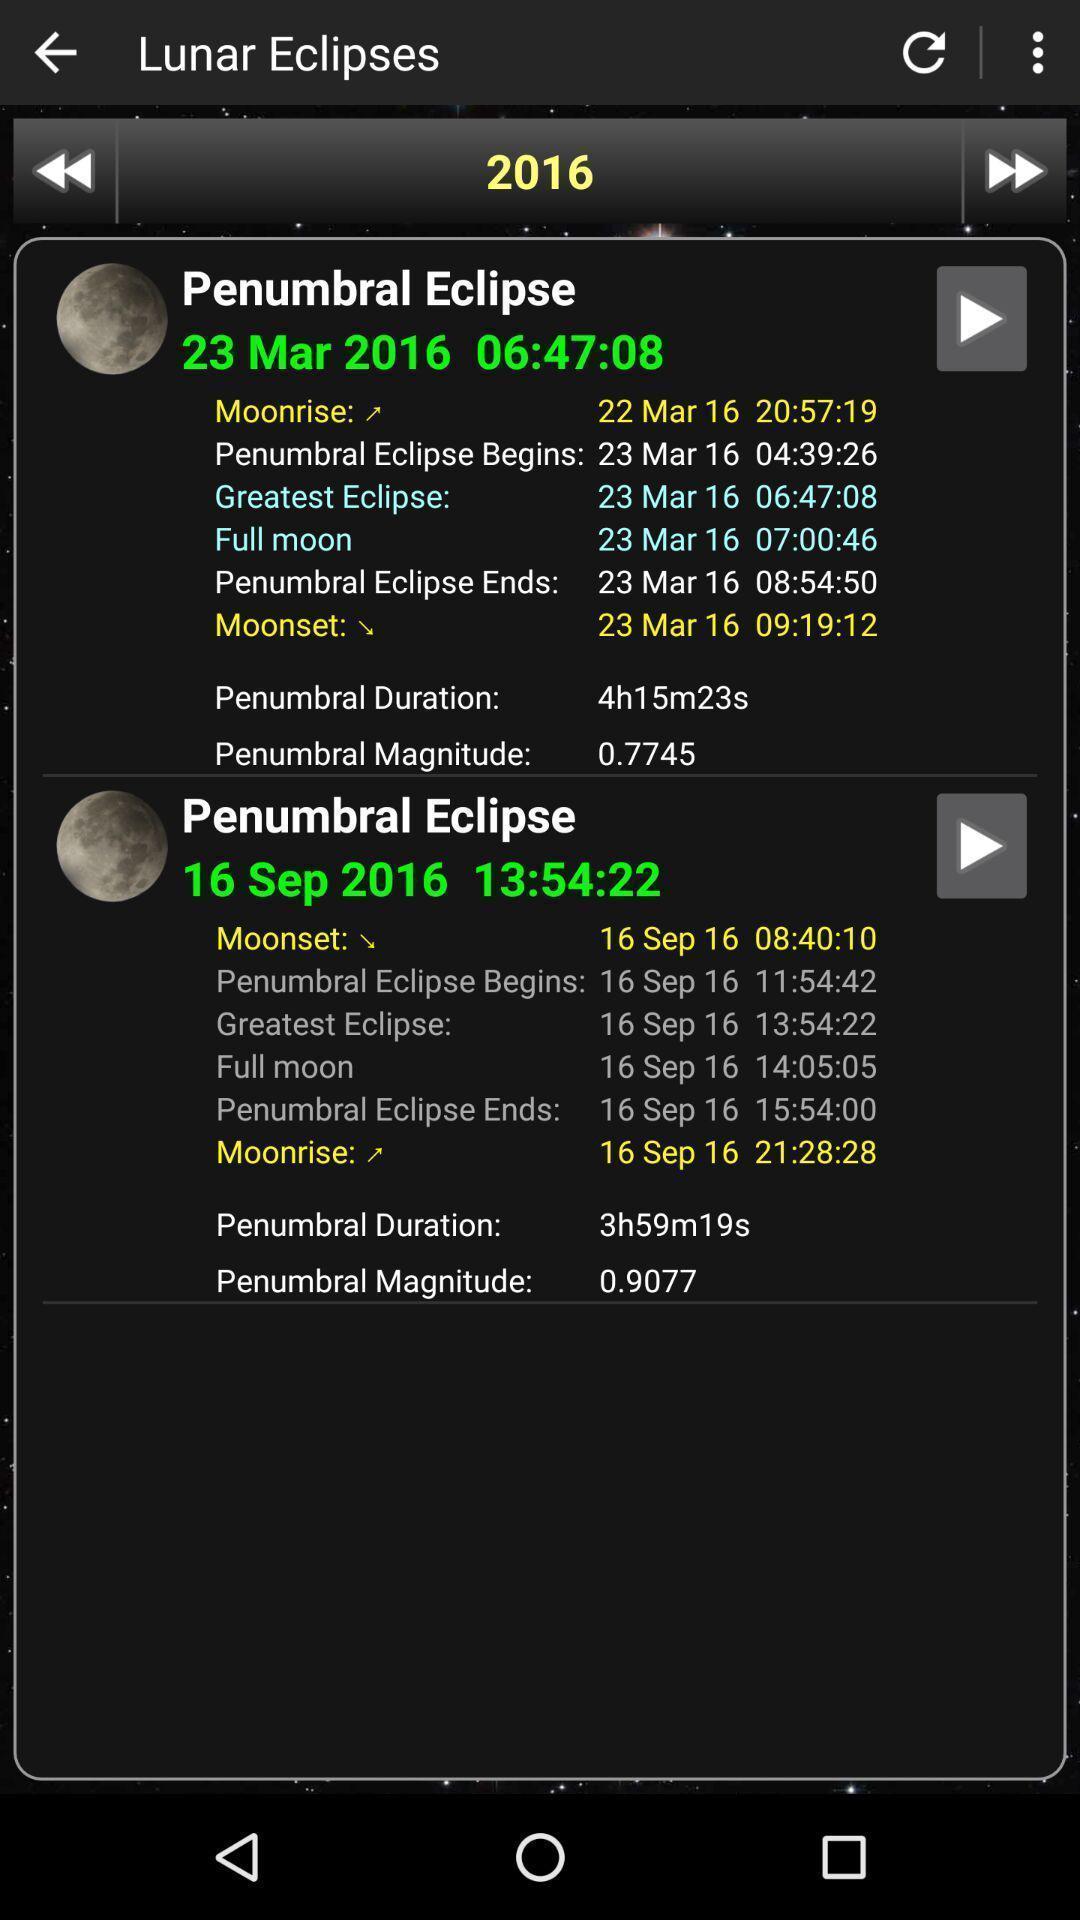Describe the visual elements of this screenshot. Screen shows multiple details. 